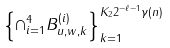<formula> <loc_0><loc_0><loc_500><loc_500>\left \{ \cap _ { i = 1 } ^ { 4 } B _ { u , w , k } ^ { ( i ) } \right \} _ { k = 1 } ^ { K _ { 2 } 2 ^ { - \ell - 1 } \gamma ( n ) }</formula> 